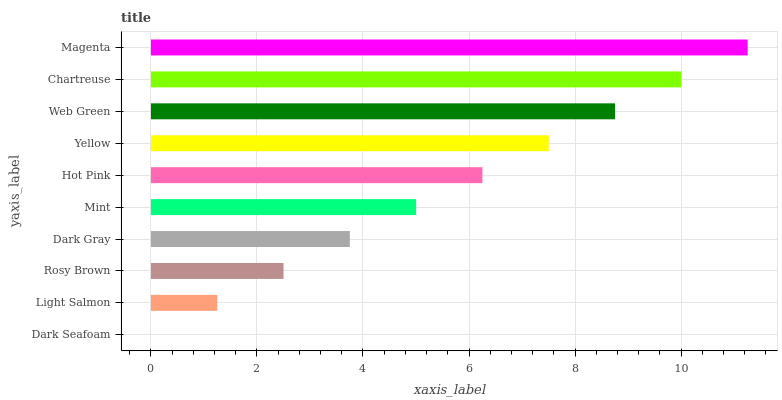Is Dark Seafoam the minimum?
Answer yes or no. Yes. Is Magenta the maximum?
Answer yes or no. Yes. Is Light Salmon the minimum?
Answer yes or no. No. Is Light Salmon the maximum?
Answer yes or no. No. Is Light Salmon greater than Dark Seafoam?
Answer yes or no. Yes. Is Dark Seafoam less than Light Salmon?
Answer yes or no. Yes. Is Dark Seafoam greater than Light Salmon?
Answer yes or no. No. Is Light Salmon less than Dark Seafoam?
Answer yes or no. No. Is Hot Pink the high median?
Answer yes or no. Yes. Is Mint the low median?
Answer yes or no. Yes. Is Dark Gray the high median?
Answer yes or no. No. Is Magenta the low median?
Answer yes or no. No. 